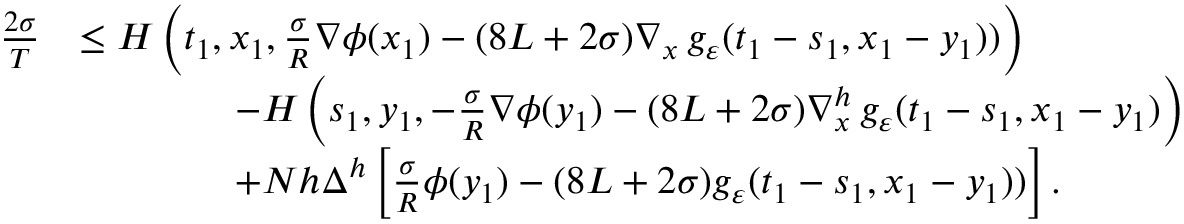Convert formula to latex. <formula><loc_0><loc_0><loc_500><loc_500>\begin{array} { r l } { \frac { 2 \sigma } { T } } & { \leq H \left ( t _ { 1 } , x _ { 1 } , \frac { \sigma } R } \nabla \phi ( x _ { 1 } ) - ( 8 L + 2 \sigma ) \nabla _ { x } \, g _ { \varepsilon } ( t _ { 1 } - s _ { 1 } , x _ { 1 } - y _ { 1 } ) ) \right ) } \\ & { \quad - H \left ( s _ { 1 } , y _ { 1 } , - \frac { \sigma } R } \nabla \phi ( y _ { 1 } ) - ( 8 L + 2 \sigma ) \nabla _ { x } ^ { h } \, g _ { \varepsilon } ( t _ { 1 } - s _ { 1 } , x _ { 1 } - y _ { 1 } ) \right ) } \\ & { \quad + N h \Delta ^ { h } \left [ \frac { \sigma } { R } \phi ( y _ { 1 } ) - ( 8 L + 2 \sigma ) g _ { \varepsilon } ( t _ { 1 } - s _ { 1 } , x _ { 1 } - y _ { 1 } ) ) \right ] . } \end{array}</formula> 